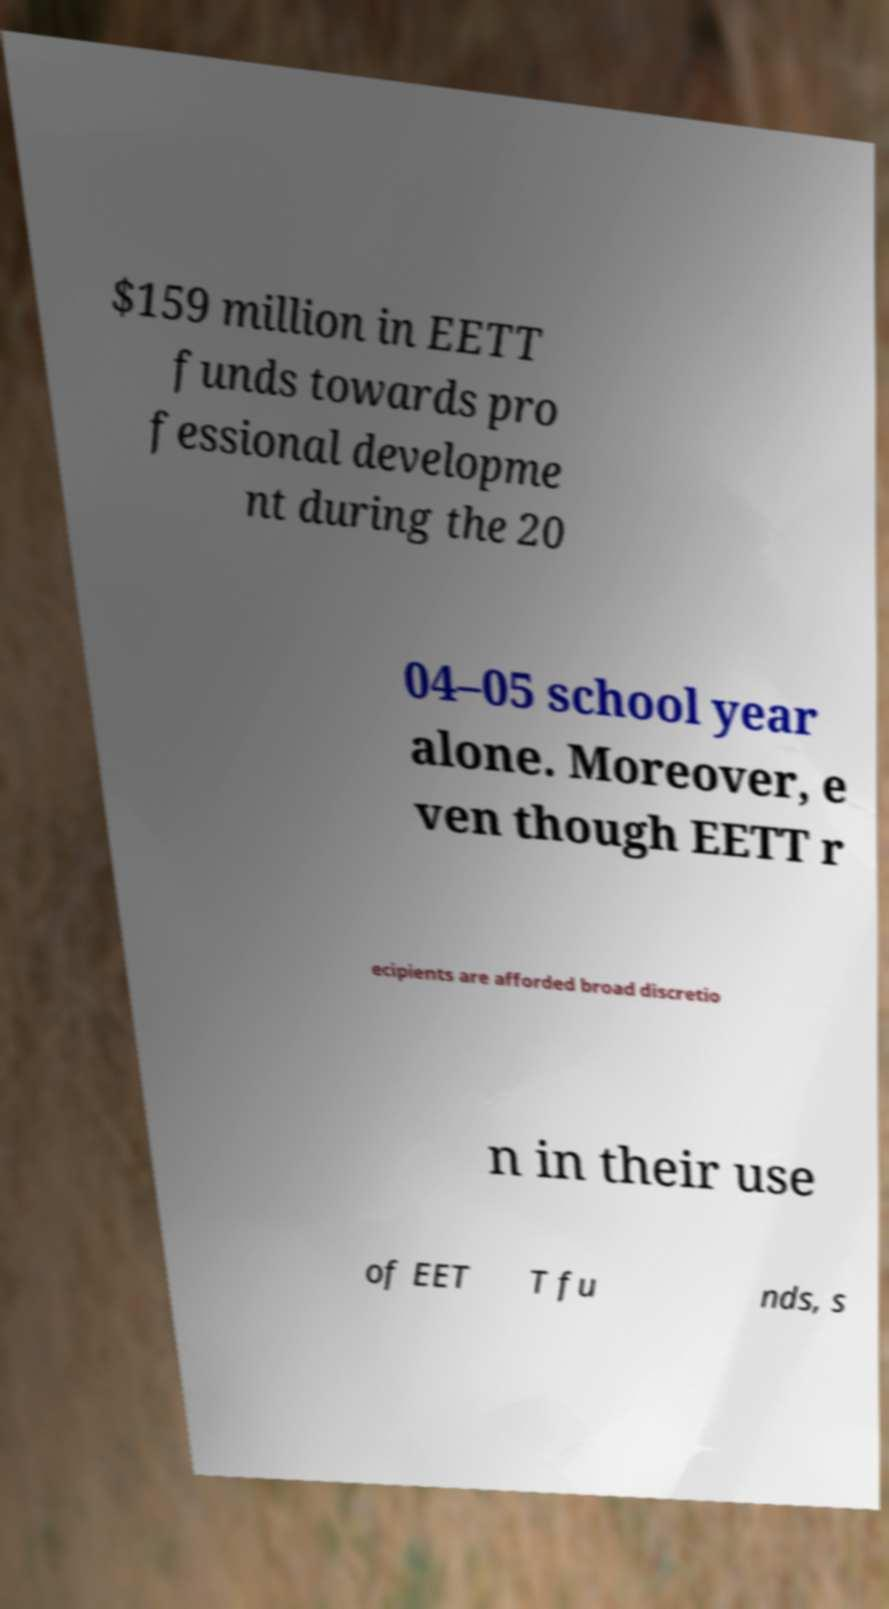What messages or text are displayed in this image? I need them in a readable, typed format. $159 million in EETT funds towards pro fessional developme nt during the 20 04–05 school year alone. Moreover, e ven though EETT r ecipients are afforded broad discretio n in their use of EET T fu nds, s 